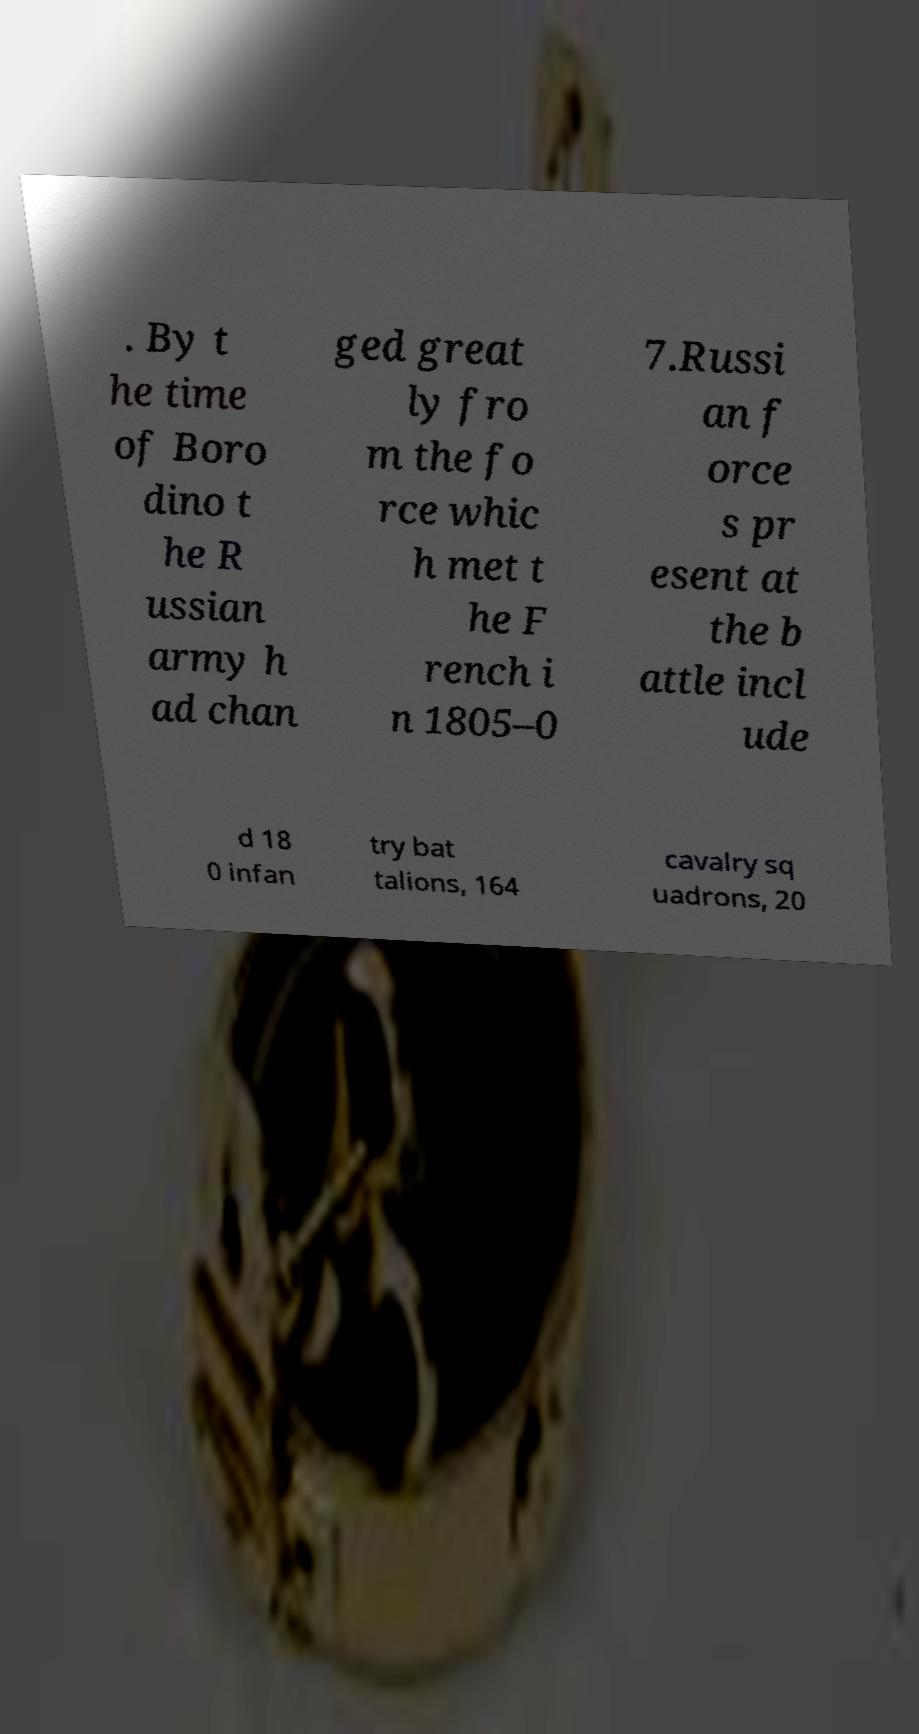For documentation purposes, I need the text within this image transcribed. Could you provide that? . By t he time of Boro dino t he R ussian army h ad chan ged great ly fro m the fo rce whic h met t he F rench i n 1805–0 7.Russi an f orce s pr esent at the b attle incl ude d 18 0 infan try bat talions, 164 cavalry sq uadrons, 20 